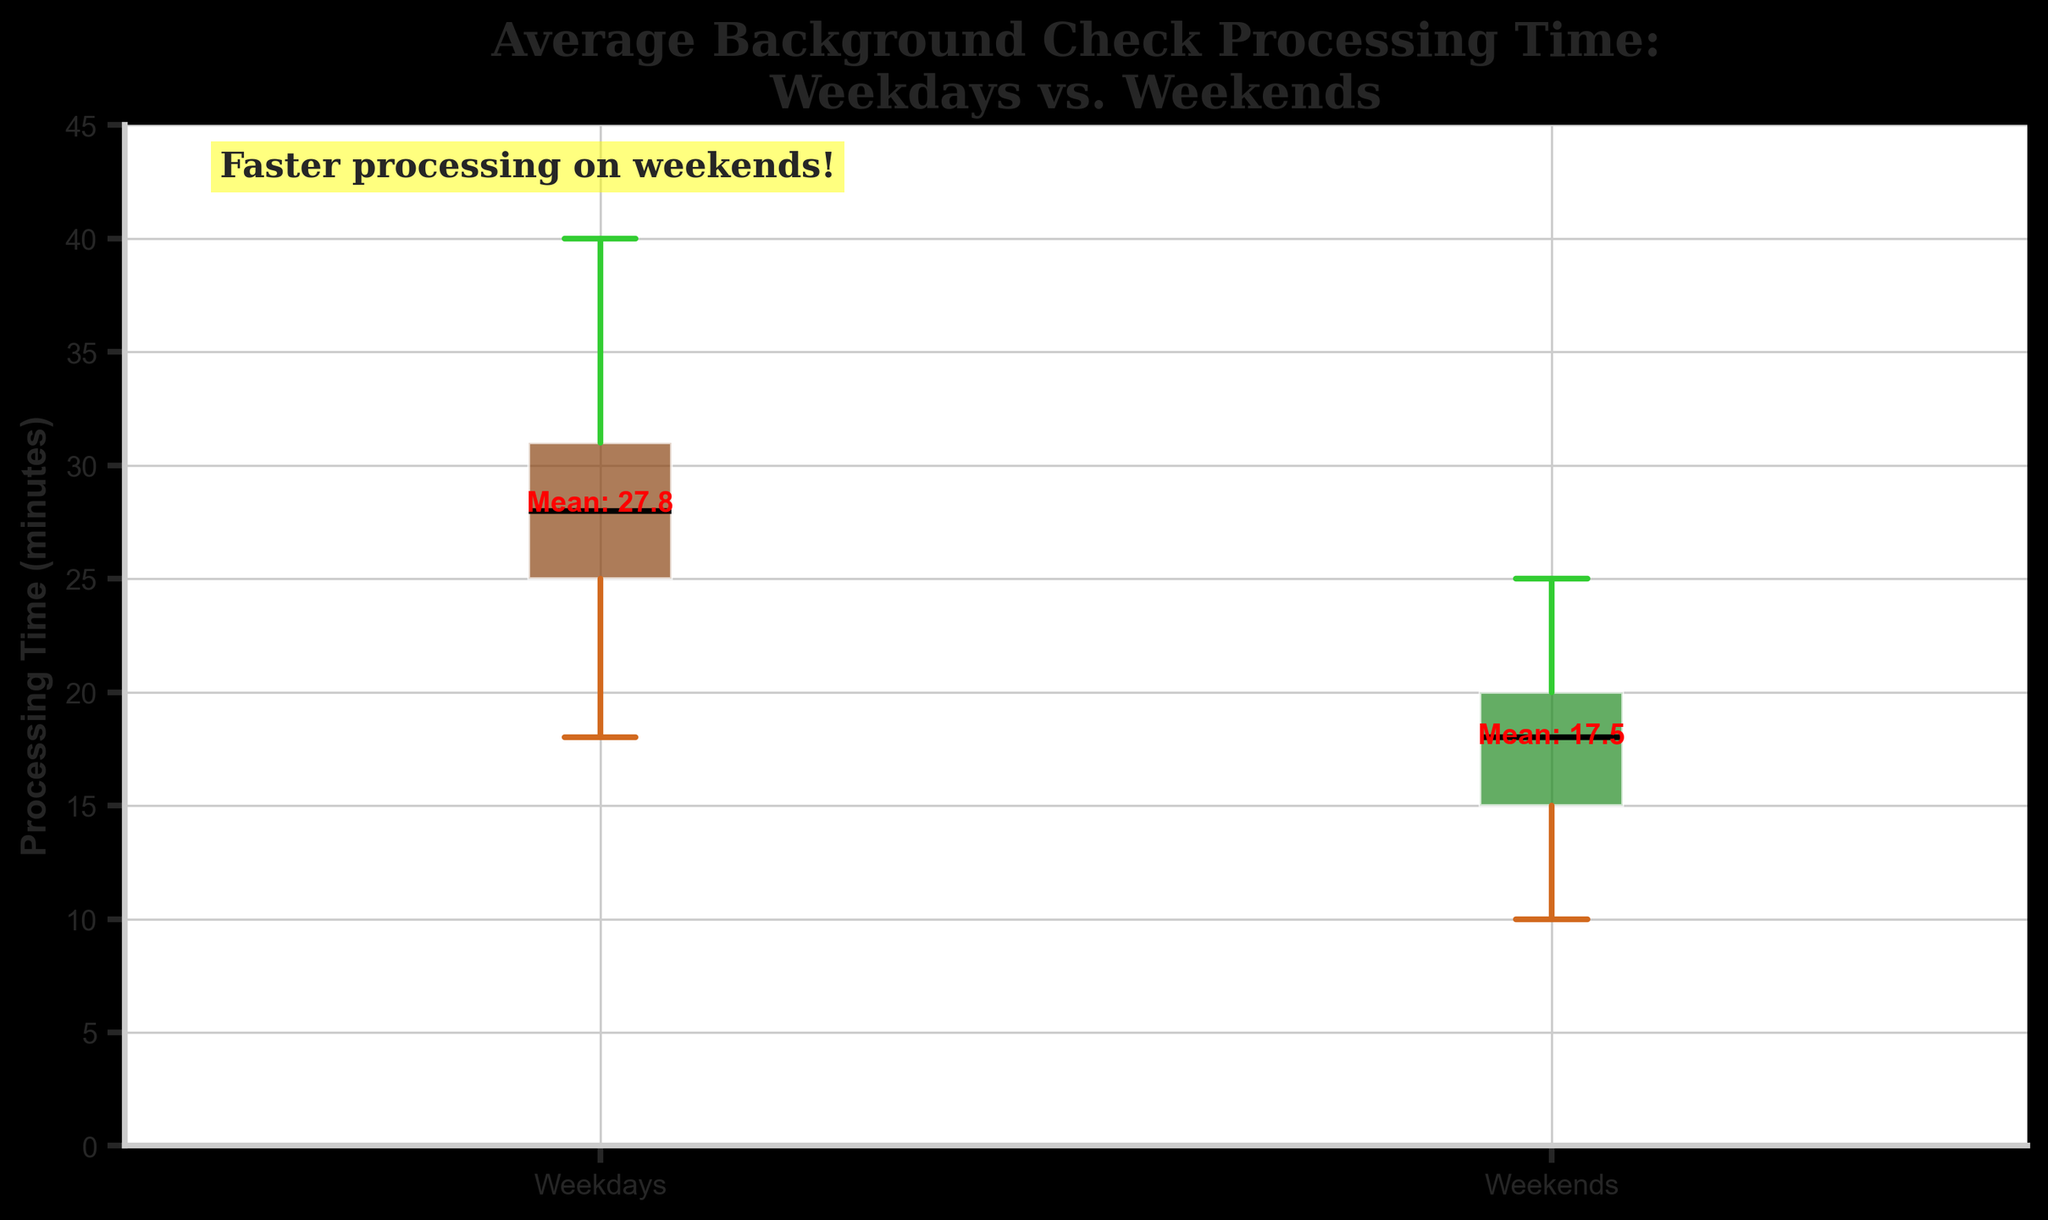What's the title of the plot? The title can be found at the top of the plot. It reads "Average Background Check Processing Time:\nWeekdays vs. Weekends".
Answer: Average Background Check Processing Time: Weekdays vs. Weekends What are the labels of the two groups in the plot? The labels can be found along the x-axis below each box plot. They are "Weekdays" and "Weekends".
Answer: Weekdays and Weekends Which day group, Weekdays or Weekends, has a higher mean processing time? From the text inside the plot, the mean processing times are noted above each box plot. Weekdays have a mean time of around 28.1 minutes, whereas Weekends have a mean time of around 16.7 minutes.
Answer: Weekdays What color represents the Weekend group in the plot? The color of the boxes for Weekends is visible and is a shade of green.
Answer: Green Is the median processing time higher on weekdays or weekends? The median is marked with a black line inside each box plot. The median line for weekdays is notably higher than the median for weekends.
Answer: Weekdays What is the approximate range of processing times on Weekdays? The range can be determined by looking at the whiskers of the box plot. For weekdays, the whiskers extend from just below 20 minutes to about 40 minutes.
Answer: ~20 to 40 minutes What does the text inside the plot suggest about processing times on weekends? The text in the upper left inside the plot specifically mentions "Faster processing on weekends!".
Answer: Faster processing on weekends How does the interquartile range (IQR) of Weekdays compare to that of Weekends? The IQR can be observed as the height of the box. The IQR for Weekdays is taller than that of Weekends, indicating greater variability in processing times during weekdays.
Answer: Larger for Weekdays What is one noticeable visual difference between the Weekday and Weekend box plots? One noticeable difference is the color of the box plots, with Weekdays in brown and Weekends in green. Additionally, the position and size of the boxes vary with Weekdays being higher and larger.
Answer: Color and height What can you infer about the consistency of processing times between Weekdays and Weekends? The shorter height of the Weekend box plot indicates more consistent (less variable) processing times compared to the Weekdays, which have a taller box plot.
Answer: More consistent on Weekends 